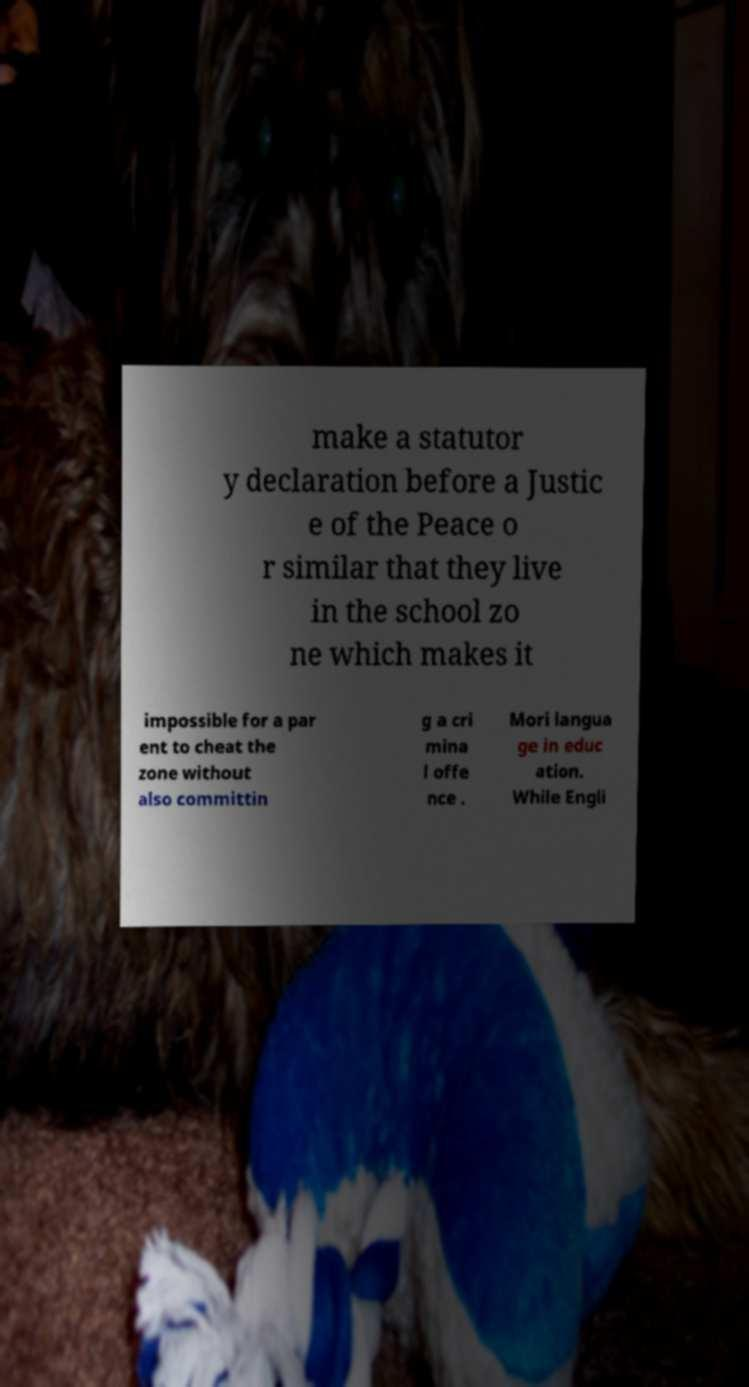Please identify and transcribe the text found in this image. make a statutor y declaration before a Justic e of the Peace o r similar that they live in the school zo ne which makes it impossible for a par ent to cheat the zone without also committin g a cri mina l offe nce . Mori langua ge in educ ation. While Engli 